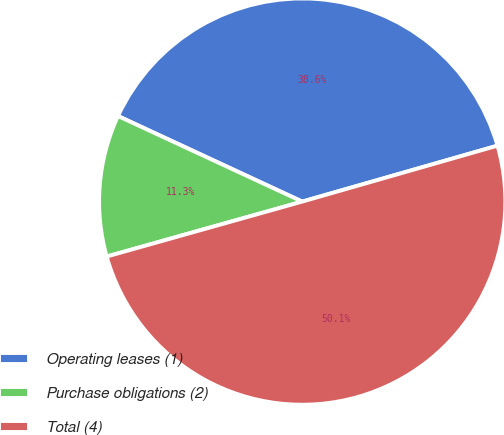Convert chart to OTSL. <chart><loc_0><loc_0><loc_500><loc_500><pie_chart><fcel>Operating leases (1)<fcel>Purchase obligations (2)<fcel>Total (4)<nl><fcel>38.64%<fcel>11.28%<fcel>50.08%<nl></chart> 